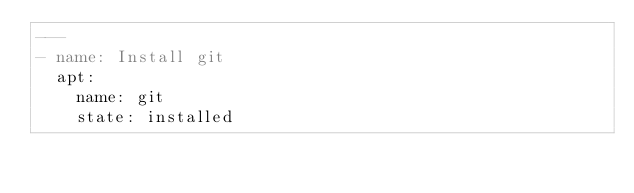Convert code to text. <code><loc_0><loc_0><loc_500><loc_500><_YAML_>---
- name: Install git
  apt:
    name: git
    state: installed
</code> 